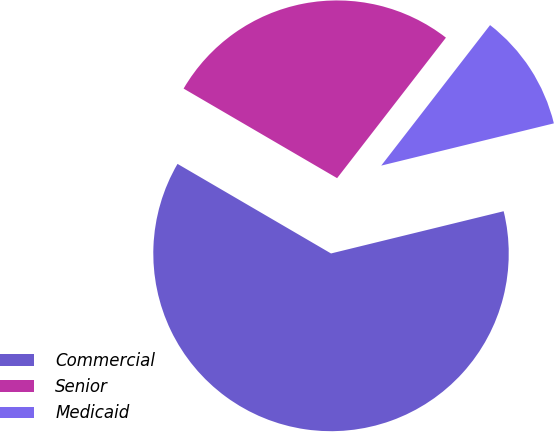Convert chart to OTSL. <chart><loc_0><loc_0><loc_500><loc_500><pie_chart><fcel>Commercial<fcel>Senior<fcel>Medicaid<nl><fcel>62.22%<fcel>27.08%<fcel>10.69%<nl></chart> 